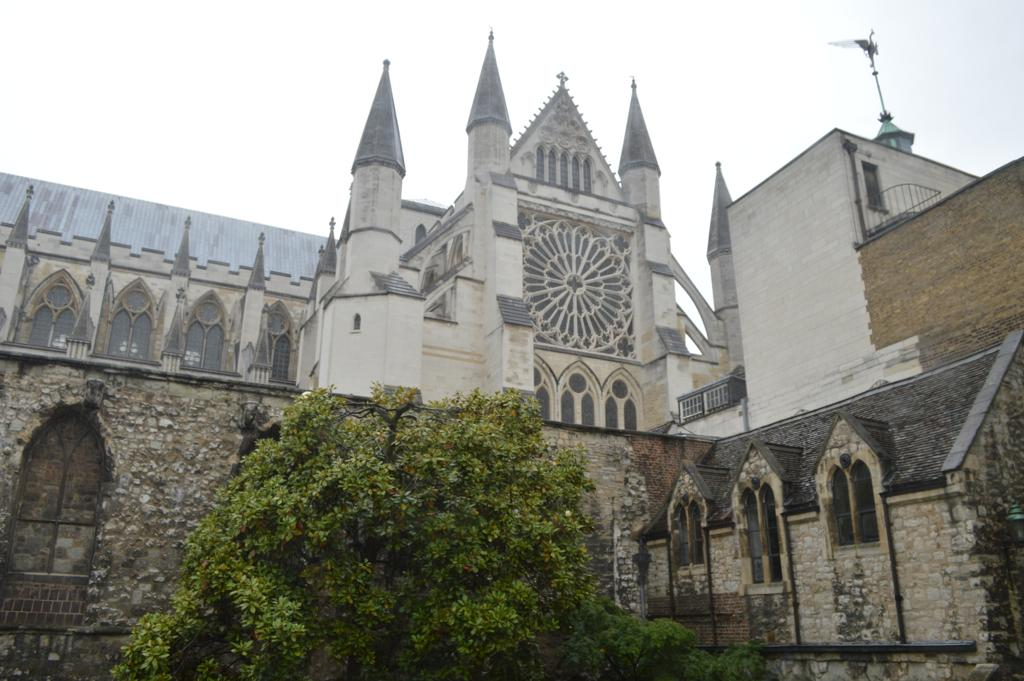What type of structure is present in the image? There is a building in the image. What type of plant can be seen in the image? There is a tree in the image. What other objects are visible in the image besides the building and tree? There are other objects in the image. What is visible at the top of the image? The sky is visible at the top of the image. How many icicles are hanging from the tree in the image? There are no icicles present in the image. What type of body is visible in the image? There is no body present in the image. 